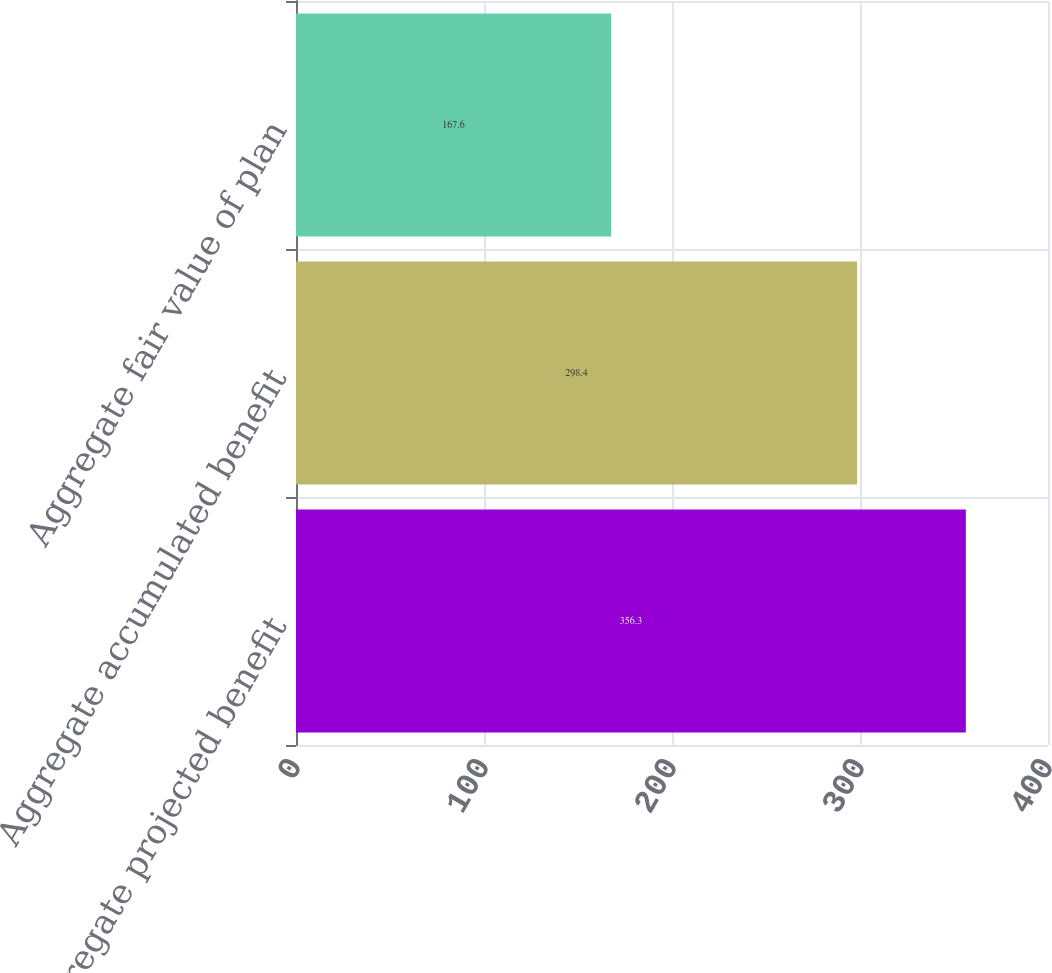Convert chart to OTSL. <chart><loc_0><loc_0><loc_500><loc_500><bar_chart><fcel>Aggregate projected benefit<fcel>Aggregate accumulated benefit<fcel>Aggregate fair value of plan<nl><fcel>356.3<fcel>298.4<fcel>167.6<nl></chart> 